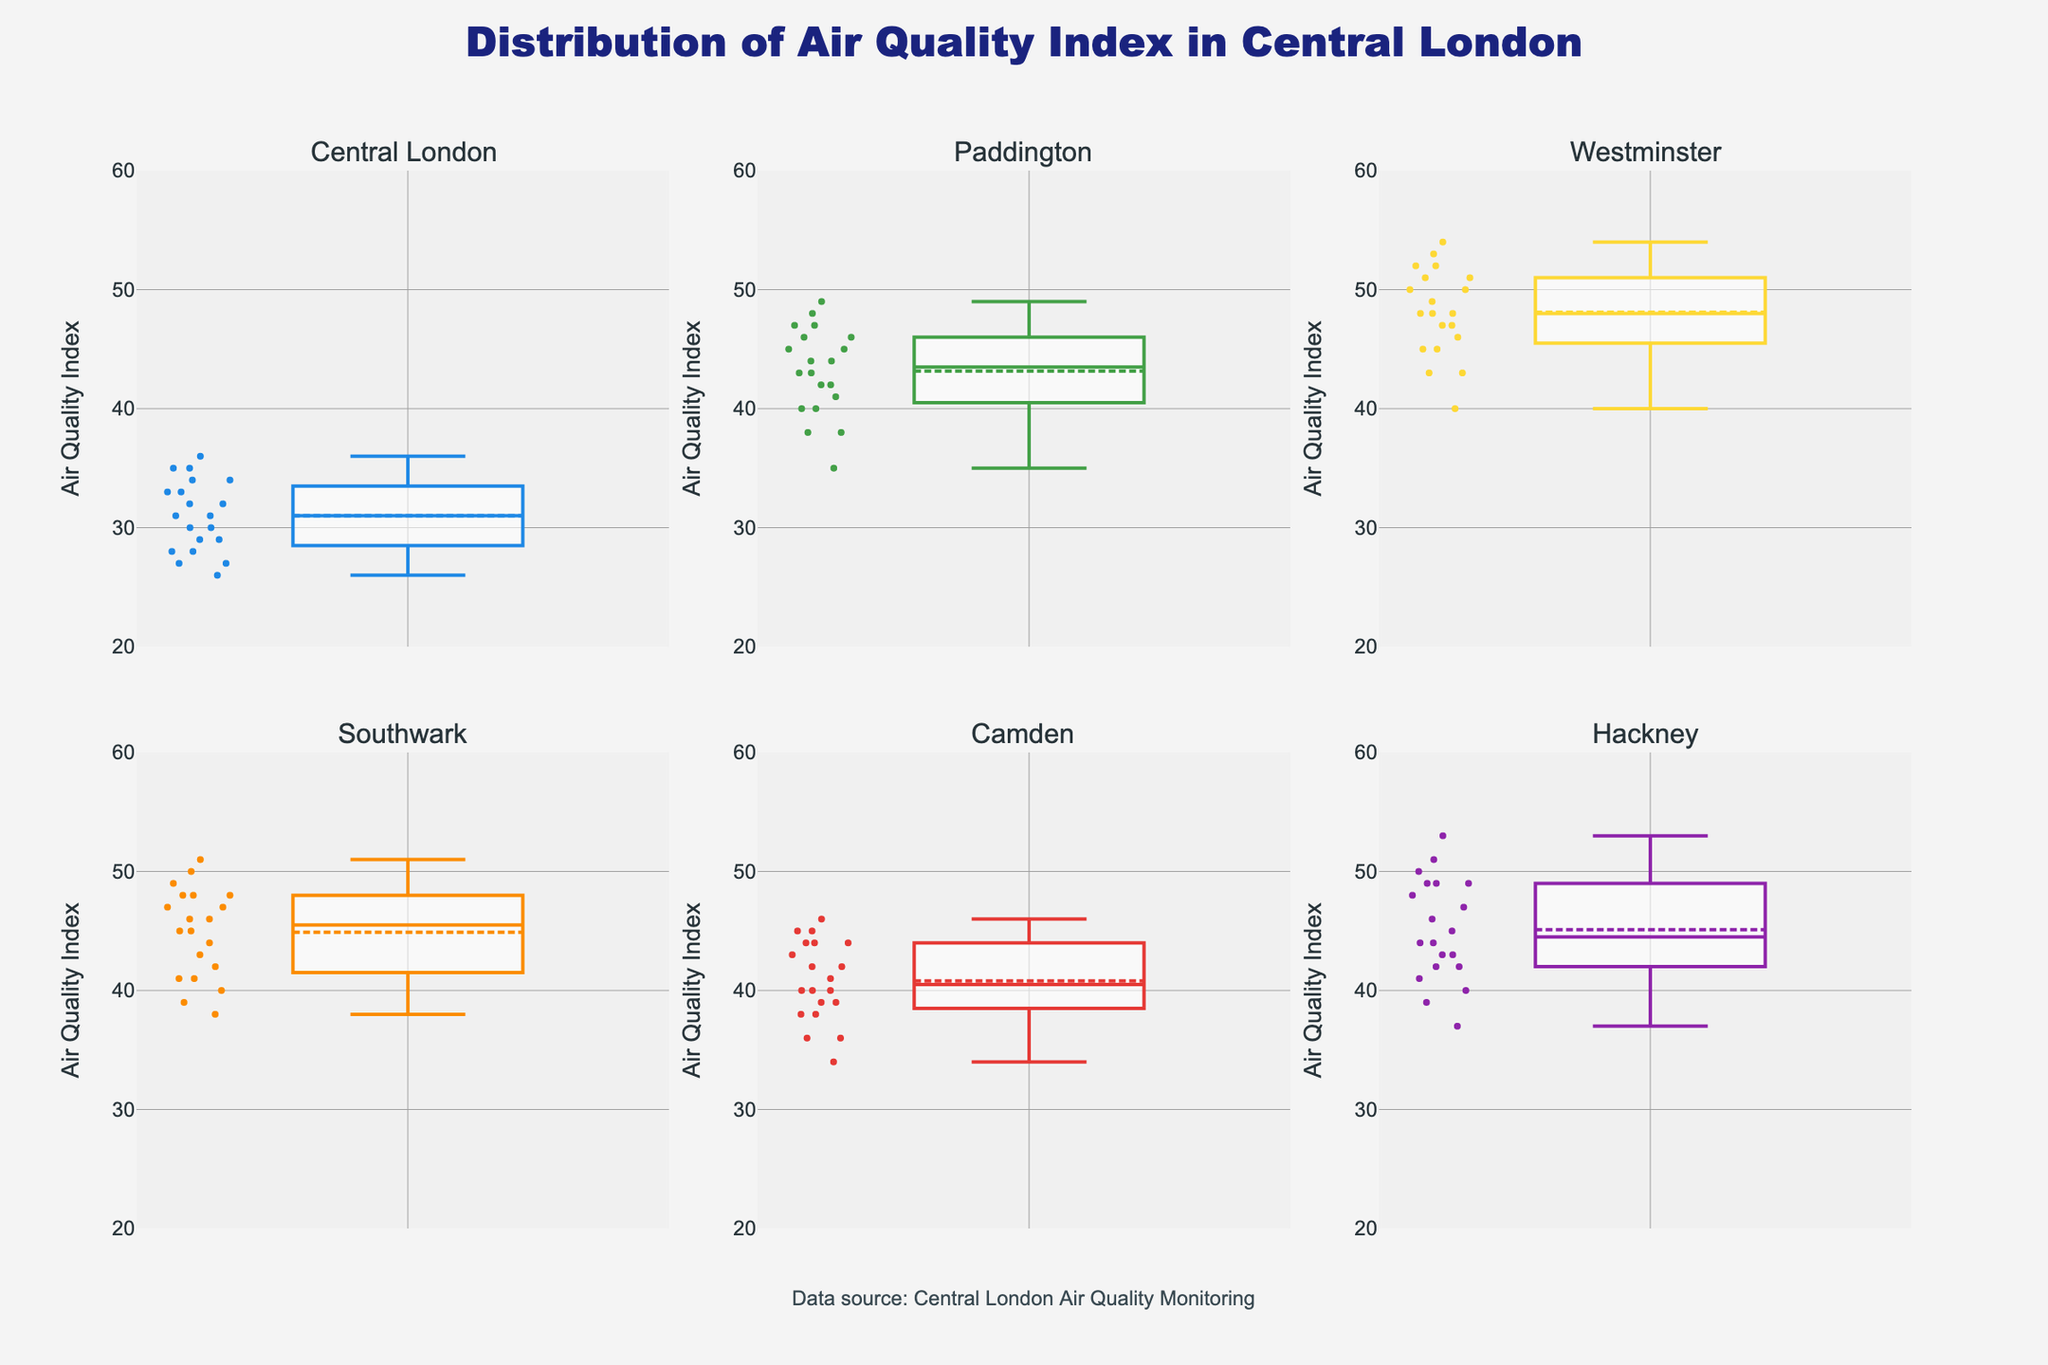What is the title of the figure? The title is located at the top center of the figure. It indicates the theme of the plot.
Answer: Distribution of Air Quality Index in Central London Which location has the highest mean AQI? To determine the highest mean AQI, look for the box plot with the highest mean line within the box plots.
Answer: Westminster Which location shows the widest range of AQI values? The range is represented by the length of the box plot. The location with the longest box plot has the widest range.
Answer: Westminster What is the range of AQI values for Southwark? Identify the minimum and maximum values from the whiskers of the box plot for Southwark. Subtract the minimum from the maximum to find the range.
Answer: 38 to 51 (range 13) Which location has the smallest interquartile range (IQR)? The IQR is the width of the box, which represents the middle 50% of the data. The location with the smallest box has the smallest IQR.
Answer: Hackney How does the median AQI for Camden compare to Paddington? Identify the median lines in the box plots for Camden and Paddington and compare their positions.
Answer: Camden's median is lower than Paddington's What is the approximate median AQI value for Central London? Locate the median line within Central London’s box plot and approximate its value based on the y-axis.
Answer: 31-33 Which location has the most consistent AQI readings? The most consistent location will show the smallest range and smallest IQR, indicated by a smaller box and whiskers.
Answer: Hackney Are there any outliers in the AQI data for Hackney? Outliers are indicated by individual points outside the whiskers of the box plots. Check if Hackney has such points.
Answer: No Based on the plots, which location would you infer has the best overall air quality? The best overall air quality will have lower median and mean AQI values compared to others.
Answer: Central London 